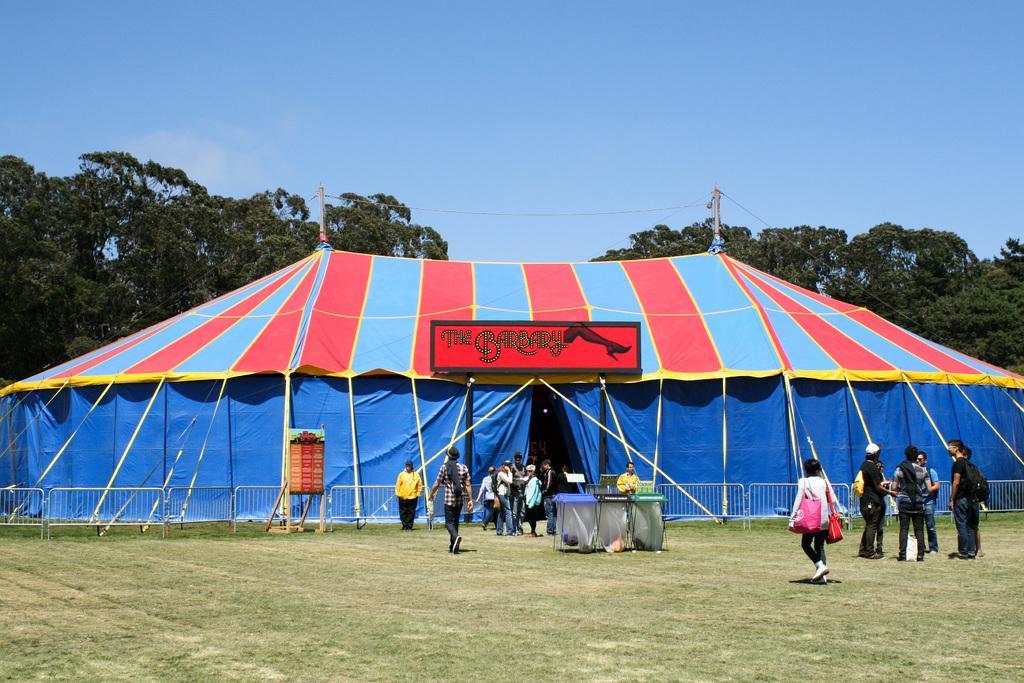How would you summarize this image in a sentence or two? In this image, we can see grass on the ground, there are some people standing, there is a tent, there are some green color trees, at the top there is a blue color sky. 